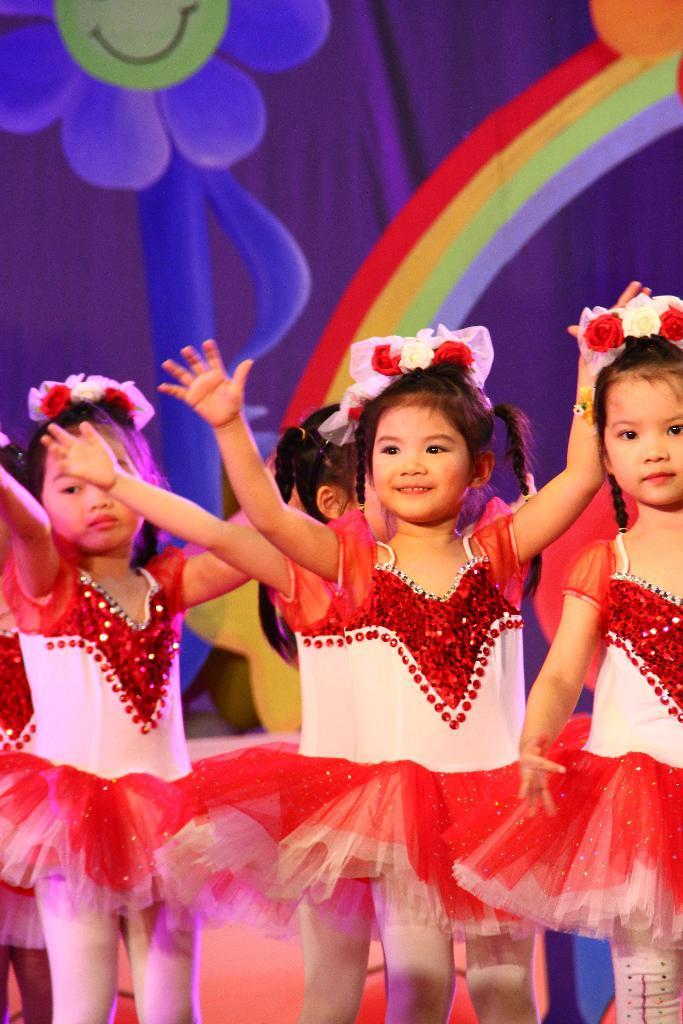How would you summarize this image in a sentence or two? In this image we can see children standing on the floor. In the background we can see a curtain. 